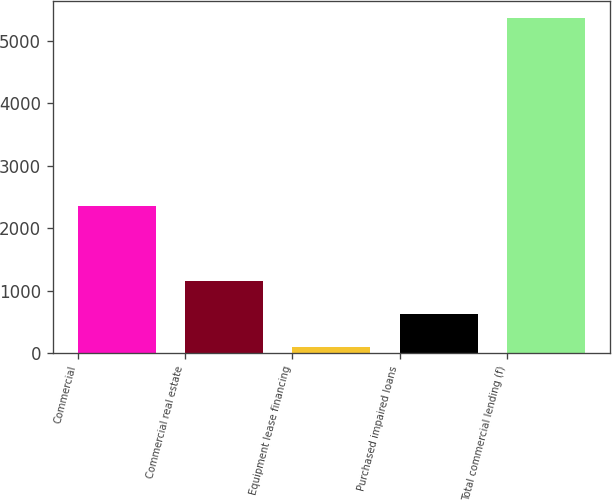<chart> <loc_0><loc_0><loc_500><loc_500><bar_chart><fcel>Commercial<fcel>Commercial real estate<fcel>Equipment lease financing<fcel>Purchased impaired loans<fcel>Total commercial lending (f)<nl><fcel>2352<fcel>1147.6<fcel>93<fcel>620.3<fcel>5366<nl></chart> 